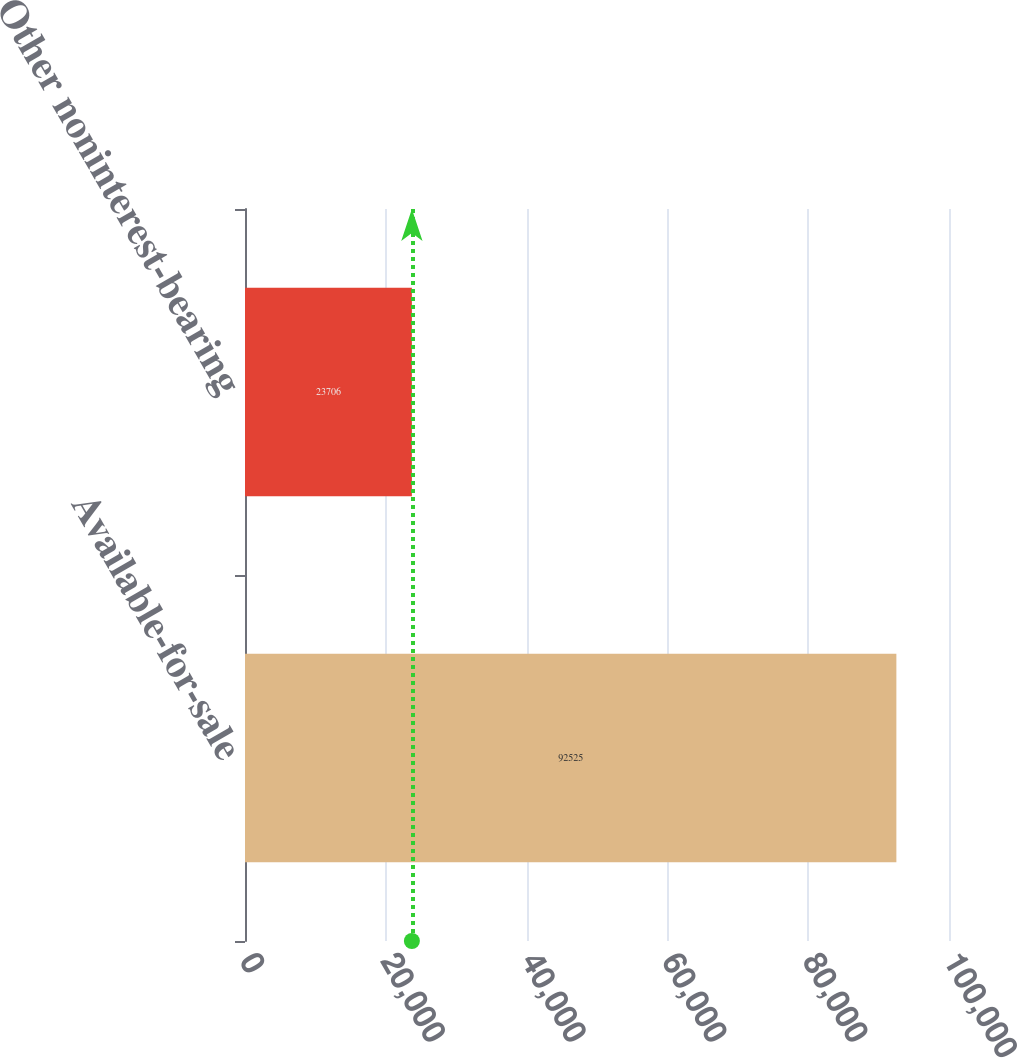<chart> <loc_0><loc_0><loc_500><loc_500><bar_chart><fcel>Available-for-sale<fcel>Other noninterest-bearing<nl><fcel>92525<fcel>23706<nl></chart> 